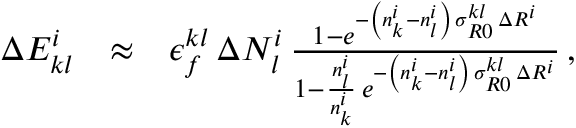<formula> <loc_0><loc_0><loc_500><loc_500>\begin{array} { r l r } { \Delta E _ { k l } ^ { i } } & { \approx } & { \epsilon _ { f } ^ { k l } \, \Delta N _ { l } ^ { i } \, \frac { 1 - e ^ { - \left ( n _ { k } ^ { i } - n _ { l } ^ { i } \right ) \, \sigma _ { R 0 } ^ { k l } \, \Delta R ^ { i } } } { 1 - \frac { n _ { l } ^ { i } } { n _ { k } ^ { i } } \, e ^ { - \left ( n _ { k } ^ { i } - n _ { l } ^ { i } \right ) \, \sigma _ { R 0 } ^ { k l } \, \Delta R ^ { i } } } \, , } \end{array}</formula> 